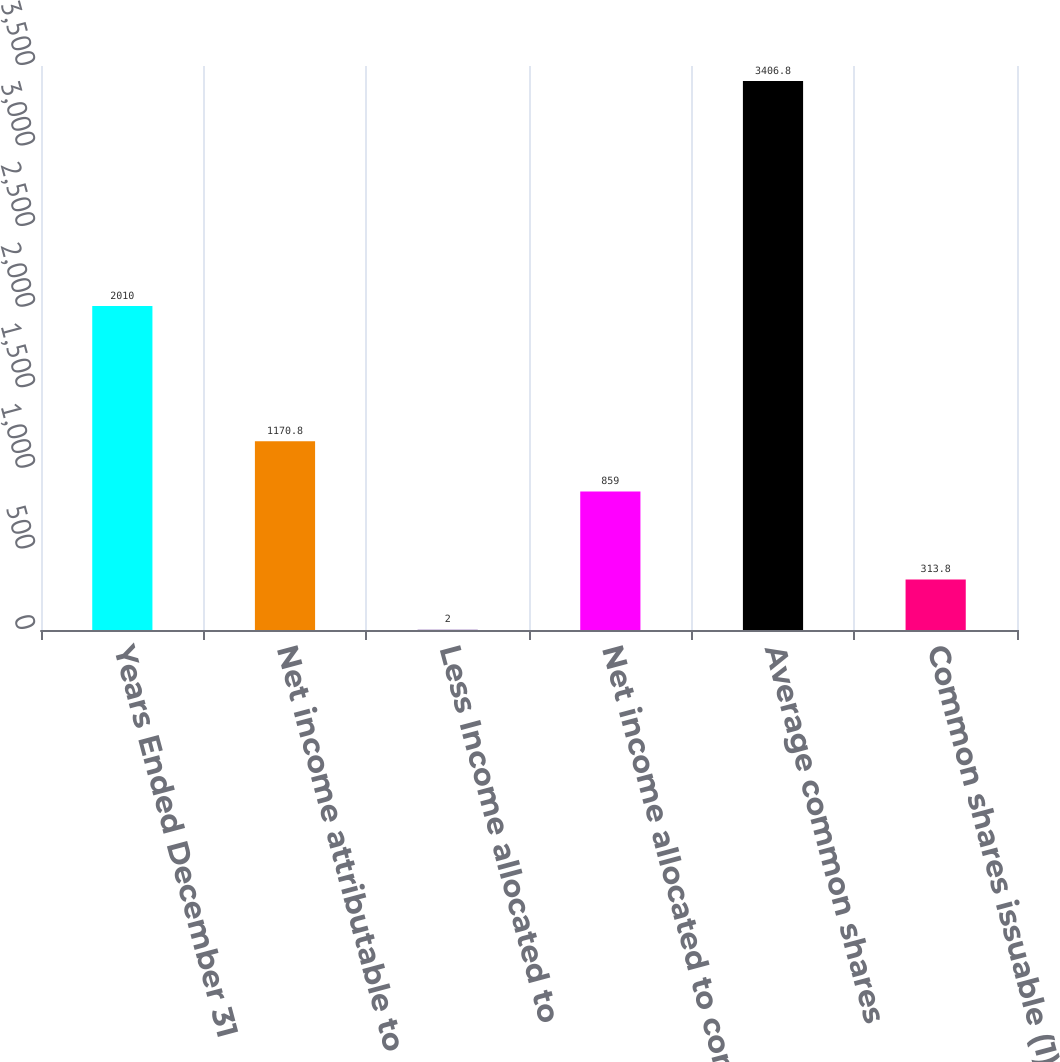Convert chart. <chart><loc_0><loc_0><loc_500><loc_500><bar_chart><fcel>Years Ended December 31<fcel>Net income attributable to<fcel>Less Income allocated to<fcel>Net income allocated to common<fcel>Average common shares<fcel>Common shares issuable (1)<nl><fcel>2010<fcel>1170.8<fcel>2<fcel>859<fcel>3406.8<fcel>313.8<nl></chart> 